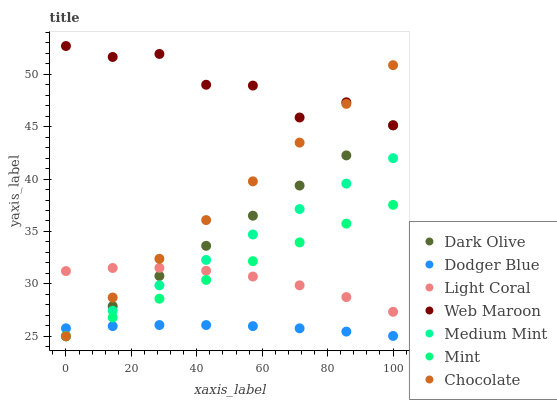Does Dodger Blue have the minimum area under the curve?
Answer yes or no. Yes. Does Web Maroon have the maximum area under the curve?
Answer yes or no. Yes. Does Dark Olive have the minimum area under the curve?
Answer yes or no. No. Does Dark Olive have the maximum area under the curve?
Answer yes or no. No. Is Dark Olive the smoothest?
Answer yes or no. Yes. Is Web Maroon the roughest?
Answer yes or no. Yes. Is Web Maroon the smoothest?
Answer yes or no. No. Is Dark Olive the roughest?
Answer yes or no. No. Does Medium Mint have the lowest value?
Answer yes or no. Yes. Does Web Maroon have the lowest value?
Answer yes or no. No. Does Web Maroon have the highest value?
Answer yes or no. Yes. Does Dark Olive have the highest value?
Answer yes or no. No. Is Dodger Blue less than Web Maroon?
Answer yes or no. Yes. Is Web Maroon greater than Mint?
Answer yes or no. Yes. Does Chocolate intersect Dodger Blue?
Answer yes or no. Yes. Is Chocolate less than Dodger Blue?
Answer yes or no. No. Is Chocolate greater than Dodger Blue?
Answer yes or no. No. Does Dodger Blue intersect Web Maroon?
Answer yes or no. No. 